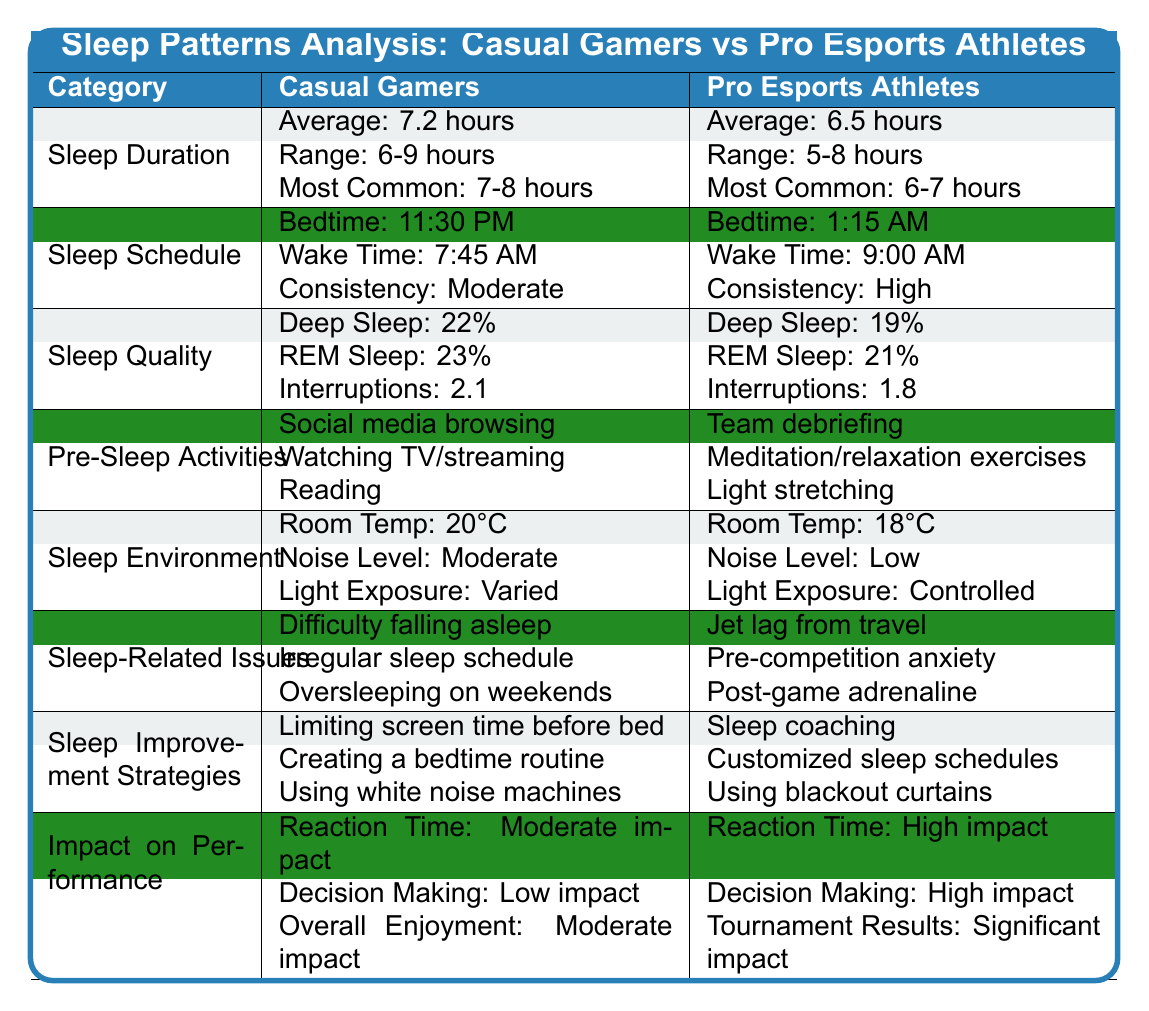What is the average sleep duration for casual gamers? The table states the average sleep duration for casual gamers as 7.2 hours.
Answer: 7.2 hours What is the most common sleep duration for pro esports athletes? The table indicates that the most common sleep duration for pro esports athletes is 6-7 hours.
Answer: 6-7 hours How many sleep interruptions do casual gamers experience on average? According to the table, casual gamers have an average of 2.1 sleep interruptions.
Answer: 2.1 What is the difference in average sleep duration between casual gamers and pro esports athletes? The average sleep duration for casual gamers is 7.2 hours, while for pro esports athletes it is 6.5 hours. The difference is calculated as 7.2 - 6.5 = 0.7 hours.
Answer: 0.7 hours Do pro esports athletes experience more deep sleep percentage compared to casual gamers? The table shows that casual gamers have 22% deep sleep, while pro esports athletes have 19%. This means pro esports athletes do not experience more deep sleep percentage.
Answer: No Which group has a higher consistency in sleep schedule? The table states casual gamers have a "Moderate" consistency while pro esports athletes have a "High" consistency in their sleep schedule, so pro esports athletes have higher consistency.
Answer: Pro esports athletes What strategies do casual gamers use to improve their sleep? The strategies listed for casual gamers include limiting screen time before bed, creating a bedtime routine, and using white noise machines.
Answer: Limiting screen time, bedtime routine, white noise How do the sleep environments of casual gamers and pro esports athletes differ in terms of noise level? The table indicates casual gamers experience a "Moderate" noise level, while pro esports athletes have a "Low" noise level. This shows that pro esports athletes have a quieter sleep environment.
Answer: Pro esports athletes have lower noise levels How does the average deep sleep percentage compare between the two groups? Casual gamers have a deep sleep percentage of 22%, while pro esports athletes have 19%. Since 22% is greater than 19%, casual gamers have a higher average deep sleep percentage.
Answer: Casual gamers have a higher average deep sleep percentage Does the table suggest that sleep-related issues are more prominent for casual gamers than pro esports athletes? The table lists several sleep-related issues for each group. Casual gamers face difficulties like falling asleep and irregular schedules, while pro esports athletes deal with jet lag and anxiety. It seems casual gamers have more varied sleep-related issues.
Answer: Yes, casual gamers have more diverse sleep-related issues 